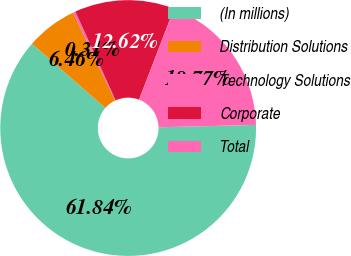Convert chart. <chart><loc_0><loc_0><loc_500><loc_500><pie_chart><fcel>(In millions)<fcel>Distribution Solutions<fcel>Technology Solutions<fcel>Corporate<fcel>Total<nl><fcel>61.85%<fcel>6.46%<fcel>0.31%<fcel>12.62%<fcel>18.77%<nl></chart> 